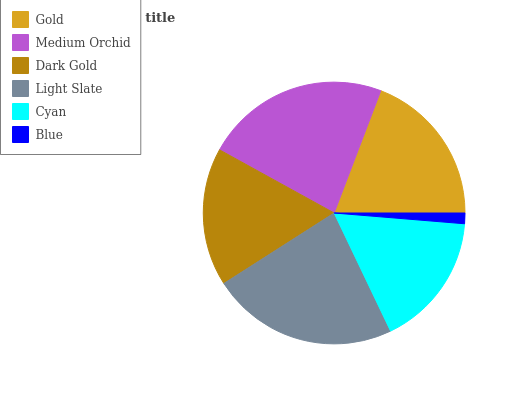Is Blue the minimum?
Answer yes or no. Yes. Is Light Slate the maximum?
Answer yes or no. Yes. Is Medium Orchid the minimum?
Answer yes or no. No. Is Medium Orchid the maximum?
Answer yes or no. No. Is Medium Orchid greater than Gold?
Answer yes or no. Yes. Is Gold less than Medium Orchid?
Answer yes or no. Yes. Is Gold greater than Medium Orchid?
Answer yes or no. No. Is Medium Orchid less than Gold?
Answer yes or no. No. Is Gold the high median?
Answer yes or no. Yes. Is Dark Gold the low median?
Answer yes or no. Yes. Is Cyan the high median?
Answer yes or no. No. Is Light Slate the low median?
Answer yes or no. No. 